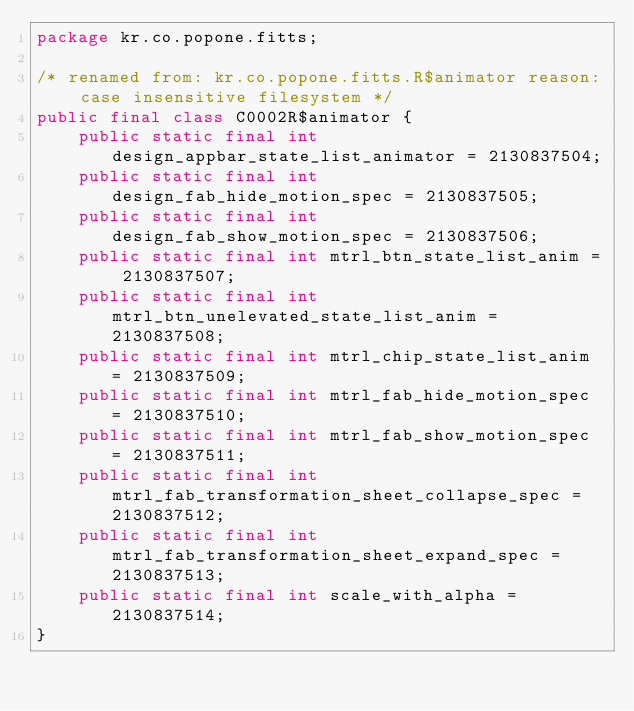<code> <loc_0><loc_0><loc_500><loc_500><_Java_>package kr.co.popone.fitts;

/* renamed from: kr.co.popone.fitts.R$animator reason: case insensitive filesystem */
public final class C0002R$animator {
    public static final int design_appbar_state_list_animator = 2130837504;
    public static final int design_fab_hide_motion_spec = 2130837505;
    public static final int design_fab_show_motion_spec = 2130837506;
    public static final int mtrl_btn_state_list_anim = 2130837507;
    public static final int mtrl_btn_unelevated_state_list_anim = 2130837508;
    public static final int mtrl_chip_state_list_anim = 2130837509;
    public static final int mtrl_fab_hide_motion_spec = 2130837510;
    public static final int mtrl_fab_show_motion_spec = 2130837511;
    public static final int mtrl_fab_transformation_sheet_collapse_spec = 2130837512;
    public static final int mtrl_fab_transformation_sheet_expand_spec = 2130837513;
    public static final int scale_with_alpha = 2130837514;
}
</code> 